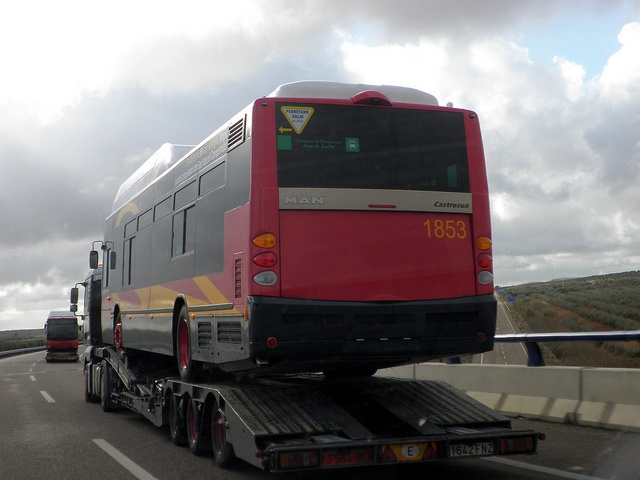Describe the objects in this image and their specific colors. I can see bus in white, black, maroon, gray, and darkgray tones, truck in white, black, and gray tones, bus in white, black, maroon, gray, and darkgray tones, and truck in white, black, maroon, darkgray, and gray tones in this image. 